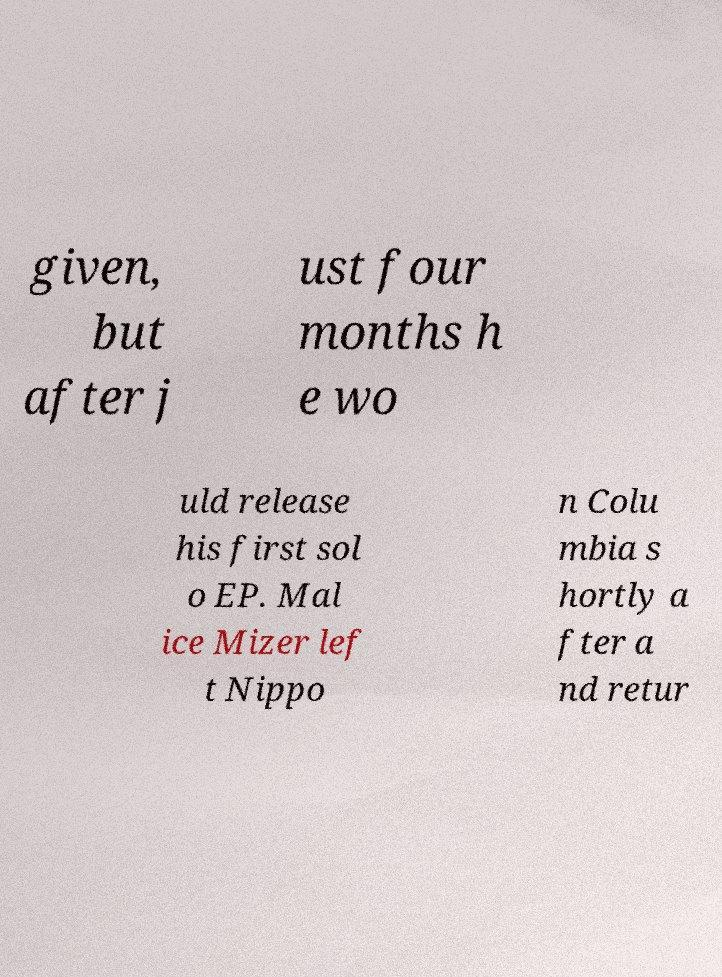Please read and relay the text visible in this image. What does it say? given, but after j ust four months h e wo uld release his first sol o EP. Mal ice Mizer lef t Nippo n Colu mbia s hortly a fter a nd retur 